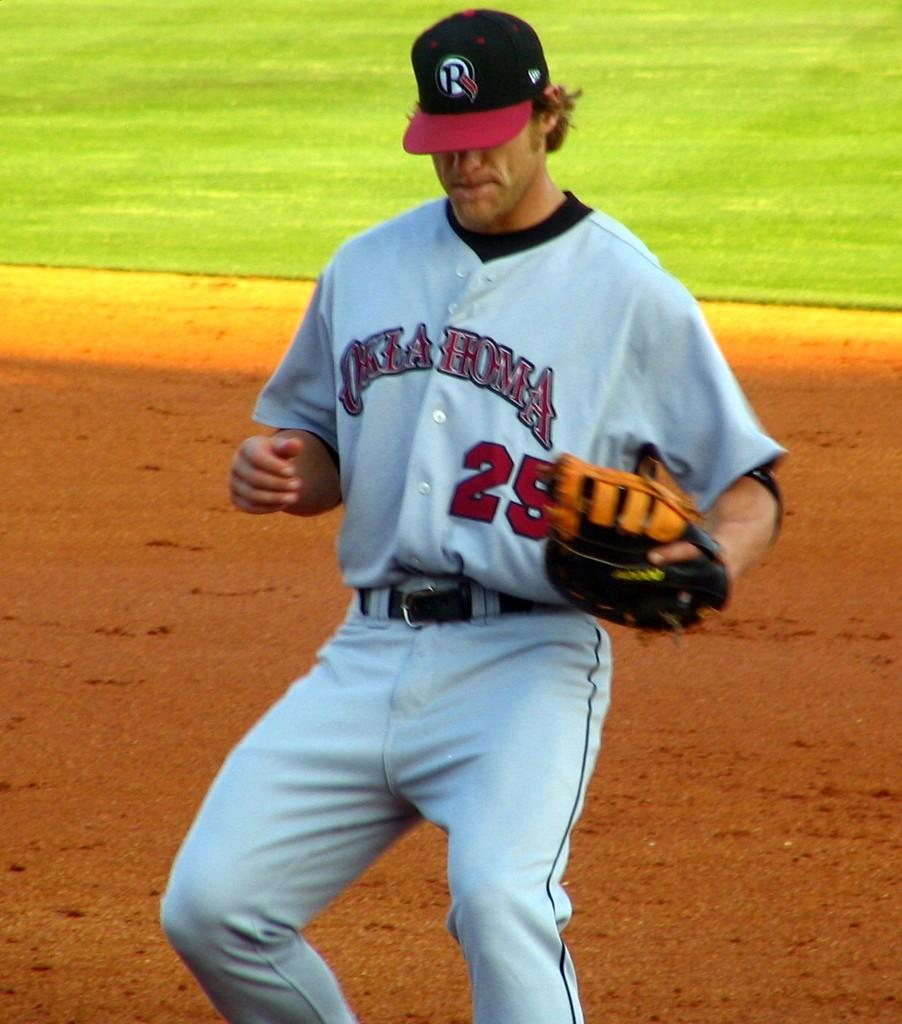<image>
Provide a brief description of the given image. number 25 from oklahoma baseball team on the field in the dirt 